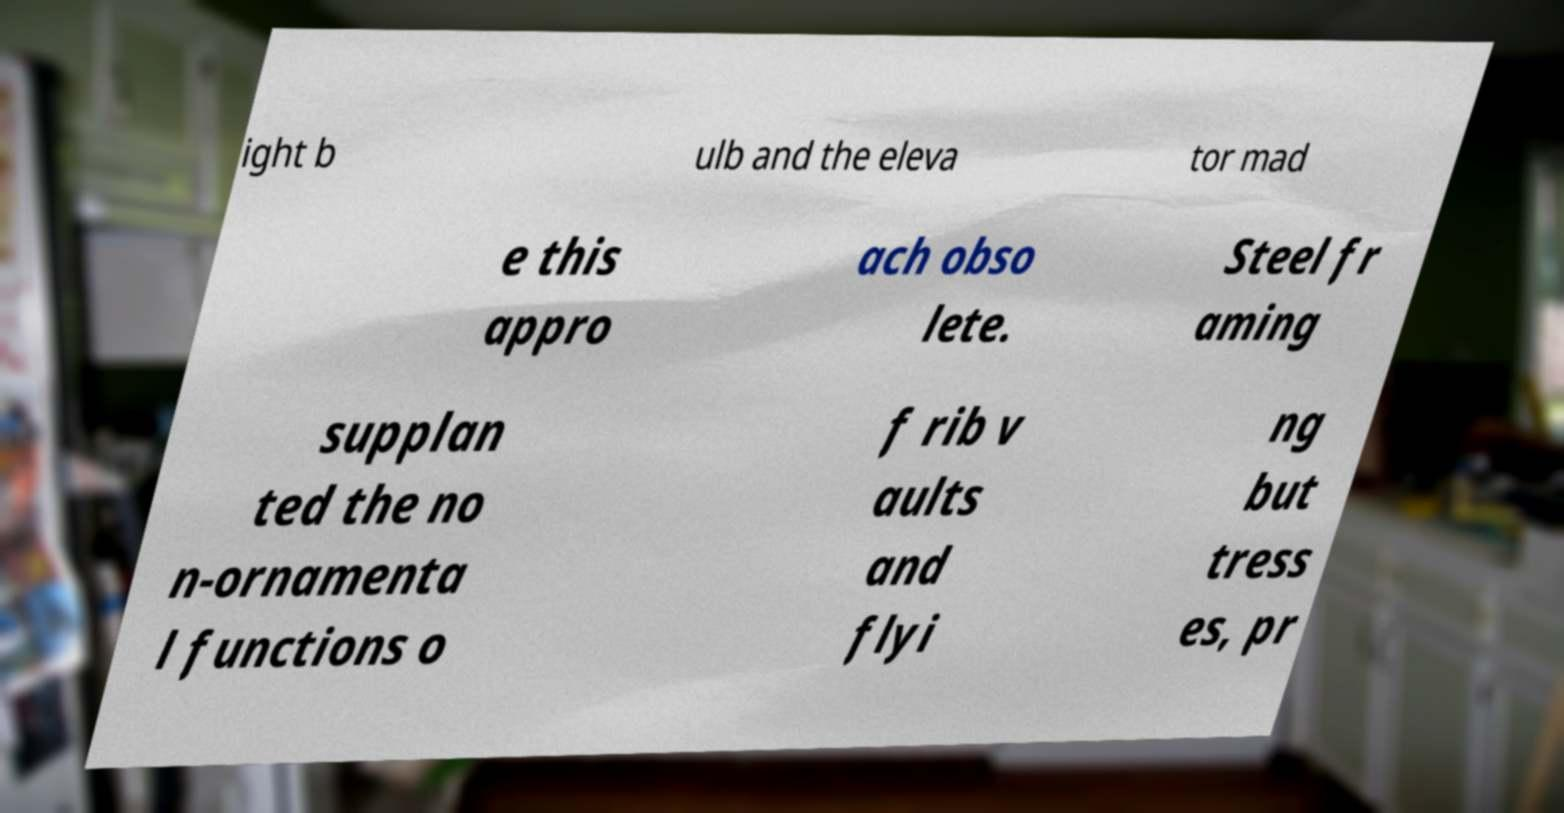Please identify and transcribe the text found in this image. ight b ulb and the eleva tor mad e this appro ach obso lete. Steel fr aming supplan ted the no n-ornamenta l functions o f rib v aults and flyi ng but tress es, pr 